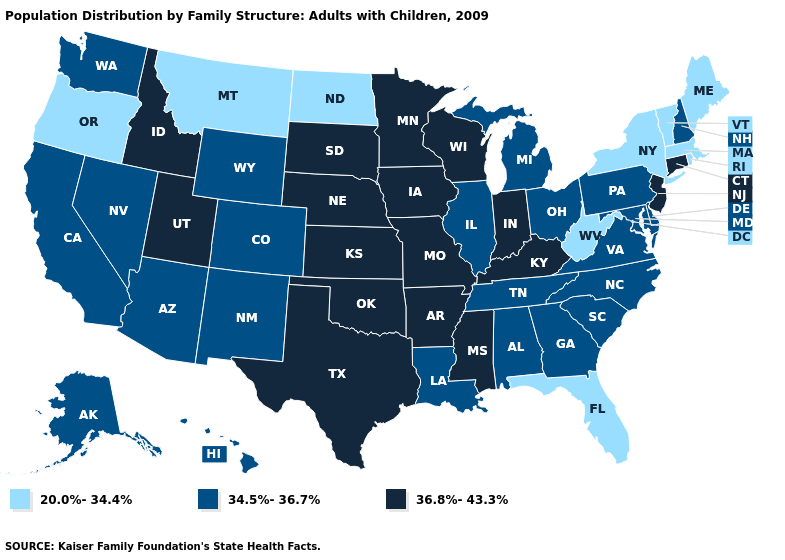Does Montana have a higher value than Georgia?
Concise answer only. No. Name the states that have a value in the range 36.8%-43.3%?
Give a very brief answer. Arkansas, Connecticut, Idaho, Indiana, Iowa, Kansas, Kentucky, Minnesota, Mississippi, Missouri, Nebraska, New Jersey, Oklahoma, South Dakota, Texas, Utah, Wisconsin. Which states have the lowest value in the South?
Answer briefly. Florida, West Virginia. What is the highest value in the USA?
Keep it brief. 36.8%-43.3%. How many symbols are there in the legend?
Answer briefly. 3. What is the value of Iowa?
Give a very brief answer. 36.8%-43.3%. Among the states that border Tennessee , which have the highest value?
Write a very short answer. Arkansas, Kentucky, Mississippi, Missouri. What is the lowest value in the West?
Quick response, please. 20.0%-34.4%. Name the states that have a value in the range 20.0%-34.4%?
Short answer required. Florida, Maine, Massachusetts, Montana, New York, North Dakota, Oregon, Rhode Island, Vermont, West Virginia. Name the states that have a value in the range 34.5%-36.7%?
Give a very brief answer. Alabama, Alaska, Arizona, California, Colorado, Delaware, Georgia, Hawaii, Illinois, Louisiana, Maryland, Michigan, Nevada, New Hampshire, New Mexico, North Carolina, Ohio, Pennsylvania, South Carolina, Tennessee, Virginia, Washington, Wyoming. Among the states that border Alabama , does Mississippi have the highest value?
Give a very brief answer. Yes. How many symbols are there in the legend?
Be succinct. 3. Name the states that have a value in the range 36.8%-43.3%?
Concise answer only. Arkansas, Connecticut, Idaho, Indiana, Iowa, Kansas, Kentucky, Minnesota, Mississippi, Missouri, Nebraska, New Jersey, Oklahoma, South Dakota, Texas, Utah, Wisconsin. Among the states that border Oregon , does Idaho have the highest value?
Concise answer only. Yes. Does New York have the highest value in the USA?
Concise answer only. No. 